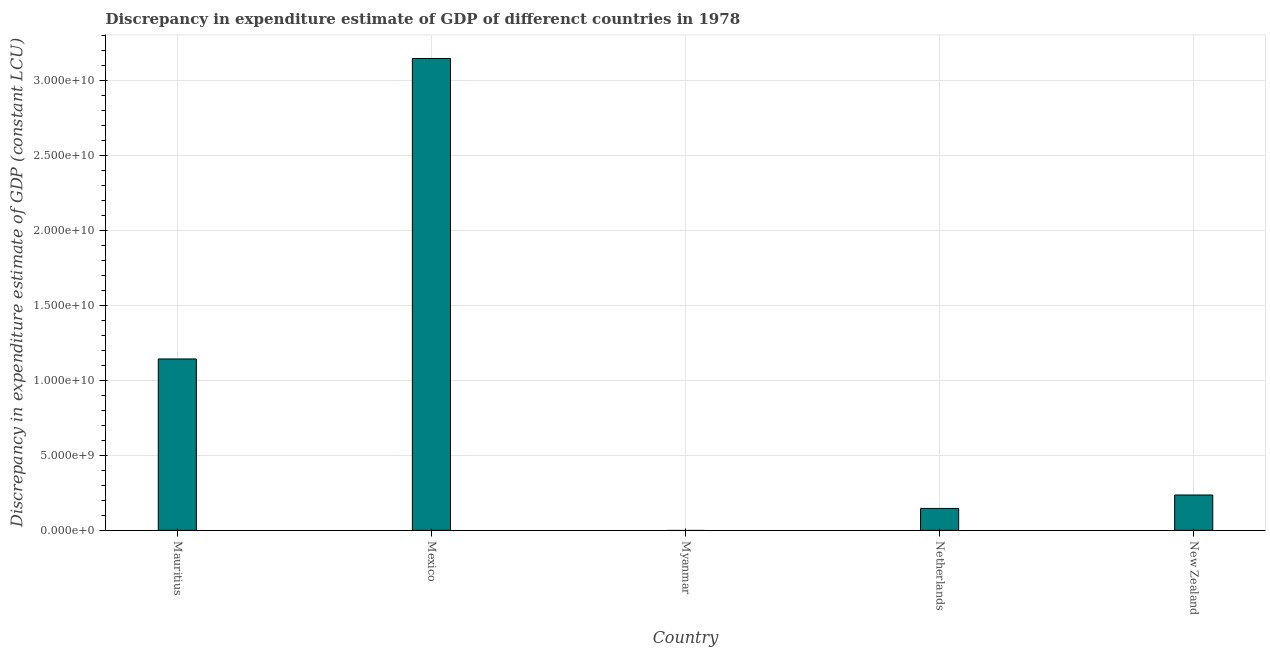Does the graph contain grids?
Your answer should be very brief. Yes. What is the title of the graph?
Give a very brief answer. Discrepancy in expenditure estimate of GDP of differenct countries in 1978. What is the label or title of the X-axis?
Ensure brevity in your answer.  Country. What is the label or title of the Y-axis?
Provide a succinct answer. Discrepancy in expenditure estimate of GDP (constant LCU). What is the discrepancy in expenditure estimate of gdp in Netherlands?
Your answer should be very brief. 1.46e+09. Across all countries, what is the maximum discrepancy in expenditure estimate of gdp?
Your answer should be compact. 3.15e+1. Across all countries, what is the minimum discrepancy in expenditure estimate of gdp?
Make the answer very short. 0. What is the sum of the discrepancy in expenditure estimate of gdp?
Provide a succinct answer. 4.67e+1. What is the difference between the discrepancy in expenditure estimate of gdp in Mauritius and Mexico?
Provide a short and direct response. -2.00e+1. What is the average discrepancy in expenditure estimate of gdp per country?
Your answer should be compact. 9.34e+09. What is the median discrepancy in expenditure estimate of gdp?
Your answer should be very brief. 2.36e+09. In how many countries, is the discrepancy in expenditure estimate of gdp greater than 1000000000 LCU?
Your answer should be compact. 4. What is the ratio of the discrepancy in expenditure estimate of gdp in Mexico to that in Netherlands?
Offer a very short reply. 21.49. Is the discrepancy in expenditure estimate of gdp in Mauritius less than that in Mexico?
Offer a terse response. Yes. Is the difference between the discrepancy in expenditure estimate of gdp in Mexico and New Zealand greater than the difference between any two countries?
Offer a terse response. No. What is the difference between the highest and the second highest discrepancy in expenditure estimate of gdp?
Provide a short and direct response. 2.00e+1. Is the sum of the discrepancy in expenditure estimate of gdp in Mauritius and Mexico greater than the maximum discrepancy in expenditure estimate of gdp across all countries?
Keep it short and to the point. Yes. What is the difference between the highest and the lowest discrepancy in expenditure estimate of gdp?
Your response must be concise. 3.15e+1. In how many countries, is the discrepancy in expenditure estimate of gdp greater than the average discrepancy in expenditure estimate of gdp taken over all countries?
Your answer should be very brief. 2. How many bars are there?
Make the answer very short. 4. How many countries are there in the graph?
Provide a succinct answer. 5. Are the values on the major ticks of Y-axis written in scientific E-notation?
Provide a short and direct response. Yes. What is the Discrepancy in expenditure estimate of GDP (constant LCU) of Mauritius?
Give a very brief answer. 1.14e+1. What is the Discrepancy in expenditure estimate of GDP (constant LCU) in Mexico?
Provide a short and direct response. 3.15e+1. What is the Discrepancy in expenditure estimate of GDP (constant LCU) of Myanmar?
Offer a very short reply. 0. What is the Discrepancy in expenditure estimate of GDP (constant LCU) in Netherlands?
Your answer should be compact. 1.46e+09. What is the Discrepancy in expenditure estimate of GDP (constant LCU) in New Zealand?
Give a very brief answer. 2.36e+09. What is the difference between the Discrepancy in expenditure estimate of GDP (constant LCU) in Mauritius and Mexico?
Offer a very short reply. -2.00e+1. What is the difference between the Discrepancy in expenditure estimate of GDP (constant LCU) in Mauritius and Netherlands?
Offer a terse response. 9.96e+09. What is the difference between the Discrepancy in expenditure estimate of GDP (constant LCU) in Mauritius and New Zealand?
Your answer should be very brief. 9.07e+09. What is the difference between the Discrepancy in expenditure estimate of GDP (constant LCU) in Mexico and Netherlands?
Provide a short and direct response. 3.00e+1. What is the difference between the Discrepancy in expenditure estimate of GDP (constant LCU) in Mexico and New Zealand?
Give a very brief answer. 2.91e+1. What is the difference between the Discrepancy in expenditure estimate of GDP (constant LCU) in Netherlands and New Zealand?
Provide a succinct answer. -8.95e+08. What is the ratio of the Discrepancy in expenditure estimate of GDP (constant LCU) in Mauritius to that in Mexico?
Keep it short and to the point. 0.36. What is the ratio of the Discrepancy in expenditure estimate of GDP (constant LCU) in Mauritius to that in Netherlands?
Your answer should be compact. 7.81. What is the ratio of the Discrepancy in expenditure estimate of GDP (constant LCU) in Mauritius to that in New Zealand?
Offer a terse response. 4.84. What is the ratio of the Discrepancy in expenditure estimate of GDP (constant LCU) in Mexico to that in Netherlands?
Make the answer very short. 21.49. What is the ratio of the Discrepancy in expenditure estimate of GDP (constant LCU) in Mexico to that in New Zealand?
Offer a terse response. 13.33. What is the ratio of the Discrepancy in expenditure estimate of GDP (constant LCU) in Netherlands to that in New Zealand?
Offer a terse response. 0.62. 